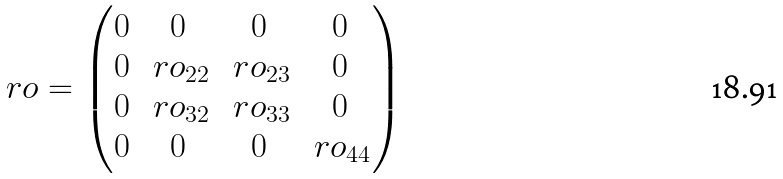<formula> <loc_0><loc_0><loc_500><loc_500>\ r o = \begin{pmatrix} 0 & 0 & 0 & 0 \\ 0 & \ r o _ { 2 2 } & \ r o _ { 2 3 } & 0 \\ 0 & \ r o _ { 3 2 } & \ r o _ { 3 3 } & 0 \\ 0 & 0 & 0 & \ r o _ { 4 4 } \end{pmatrix}</formula> 